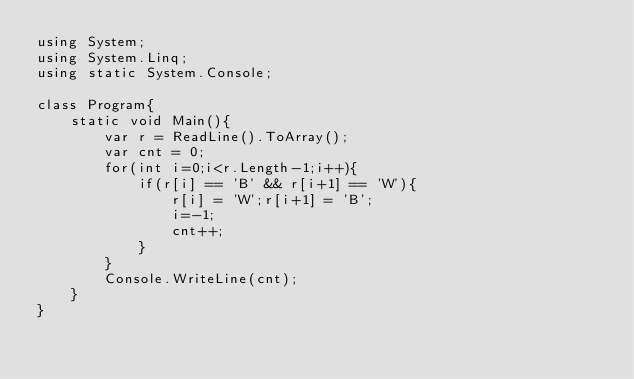<code> <loc_0><loc_0><loc_500><loc_500><_C#_>using System;
using System.Linq;
using static System.Console;

class Program{
    static void Main(){
        var r = ReadLine().ToArray();
        var cnt = 0;
        for(int i=0;i<r.Length-1;i++){
            if(r[i] == 'B' && r[i+1] == 'W'){
                r[i] = 'W';r[i+1] = 'B';
                i=-1;
                cnt++;
            }
        }
        Console.WriteLine(cnt);
    }
}</code> 